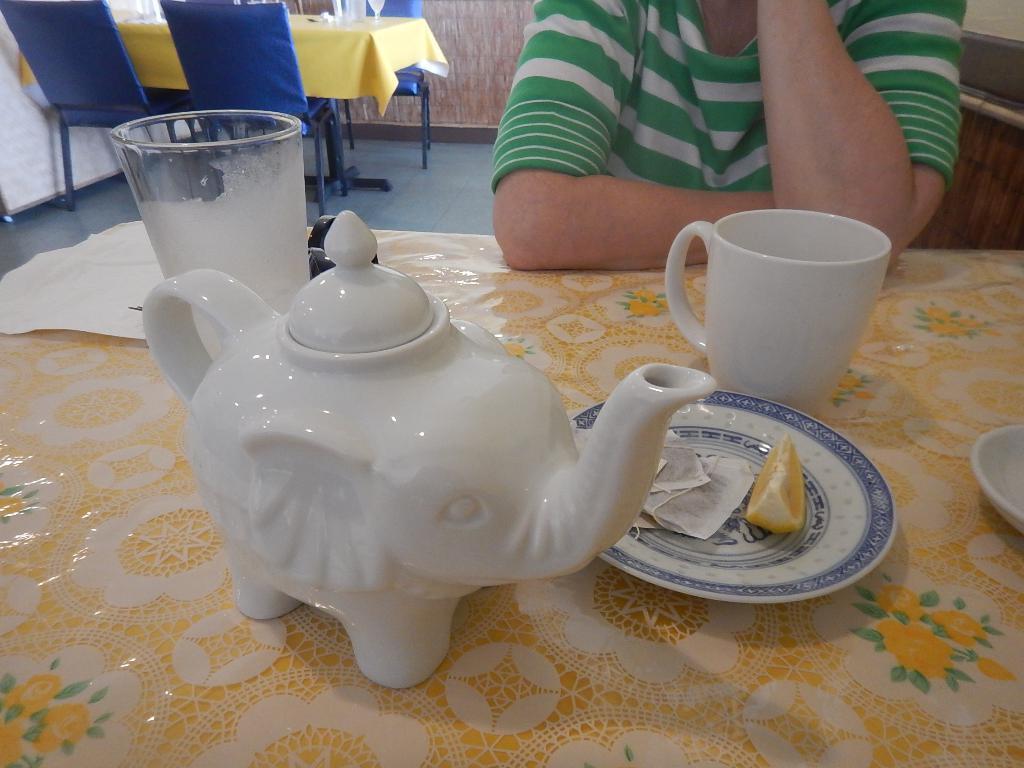Please provide a concise description of this image. In the given image we can see that, the person sitting on chair, in front of him there is a tea cup, glass and a plate. There is an orange slice in a plate. 